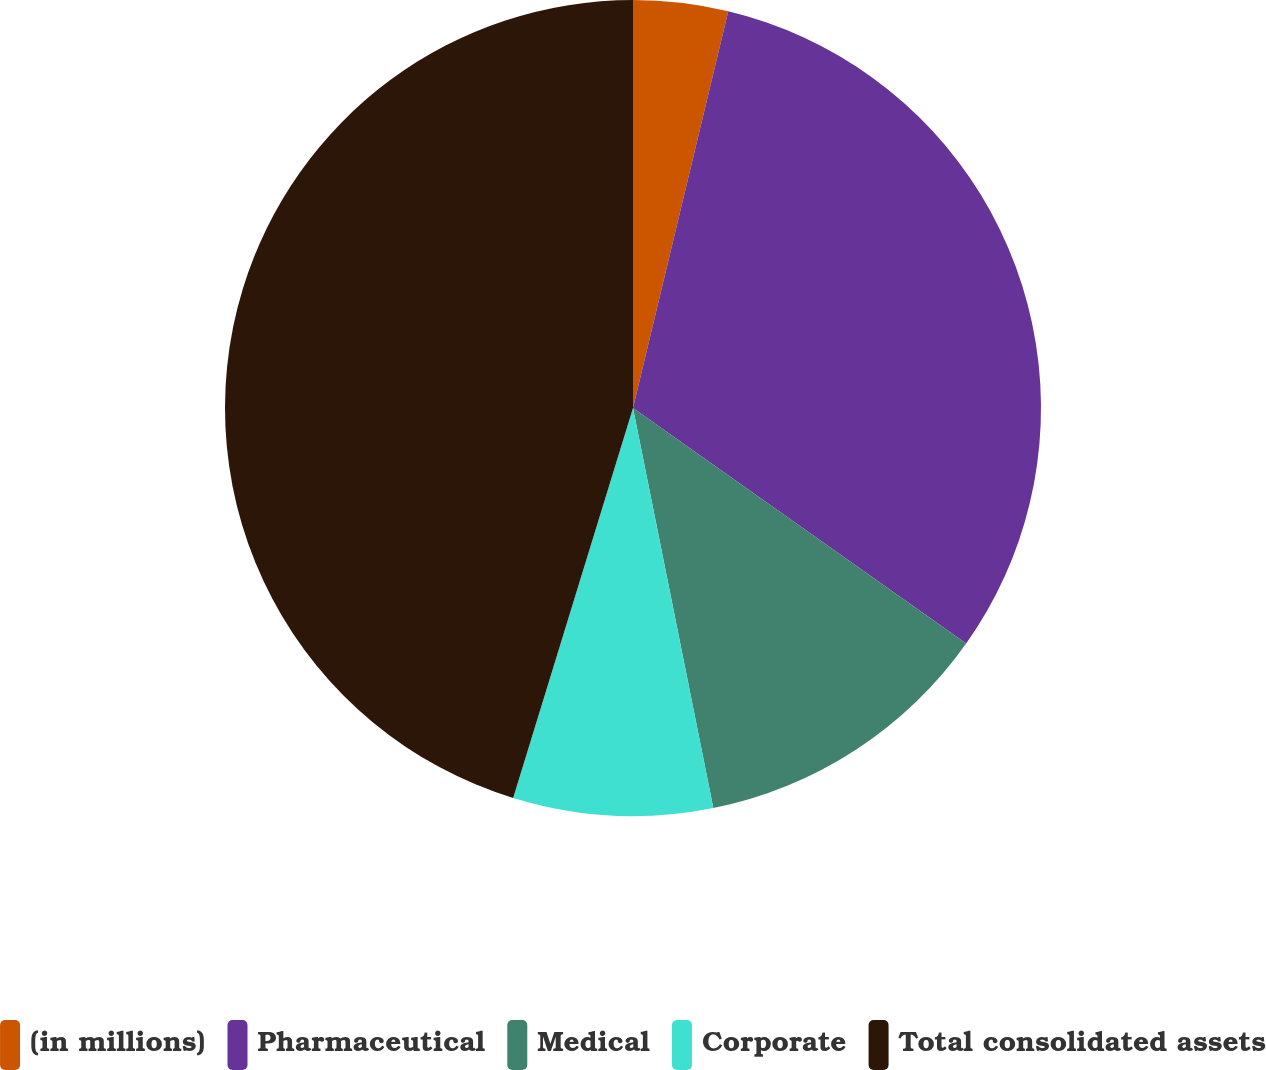Convert chart to OTSL. <chart><loc_0><loc_0><loc_500><loc_500><pie_chart><fcel>(in millions)<fcel>Pharmaceutical<fcel>Medical<fcel>Corporate<fcel>Total consolidated assets<nl><fcel>3.75%<fcel>31.04%<fcel>12.05%<fcel>7.9%<fcel>45.25%<nl></chart> 